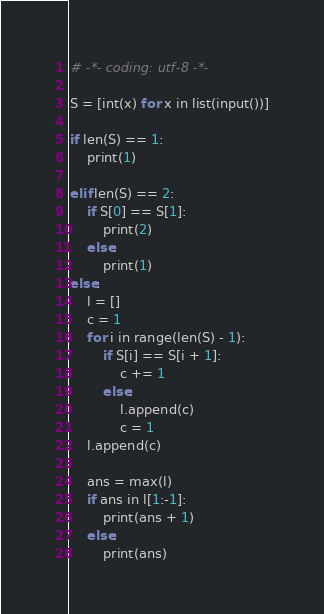<code> <loc_0><loc_0><loc_500><loc_500><_Python_># -*- coding: utf-8 -*-

S = [int(x) for x in list(input())]

if len(S) == 1:
    print(1)

elif len(S) == 2:
    if S[0] == S[1]:
        print(2)
    else:
        print(1)
else:
    l = []
    c = 1
    for i in range(len(S) - 1):
        if S[i] == S[i + 1]:
            c += 1
        else:
            l.append(c)
            c = 1
    l.append(c)

    ans = max(l)
    if ans in l[1:-1]:
        print(ans + 1)
    else:
        print(ans)
</code> 